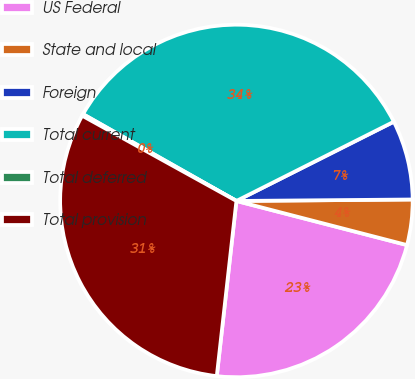<chart> <loc_0><loc_0><loc_500><loc_500><pie_chart><fcel>US Federal<fcel>State and local<fcel>Foreign<fcel>Total current<fcel>Total deferred<fcel>Total provision<nl><fcel>22.75%<fcel>4.16%<fcel>7.29%<fcel>34.38%<fcel>0.16%<fcel>31.26%<nl></chart> 